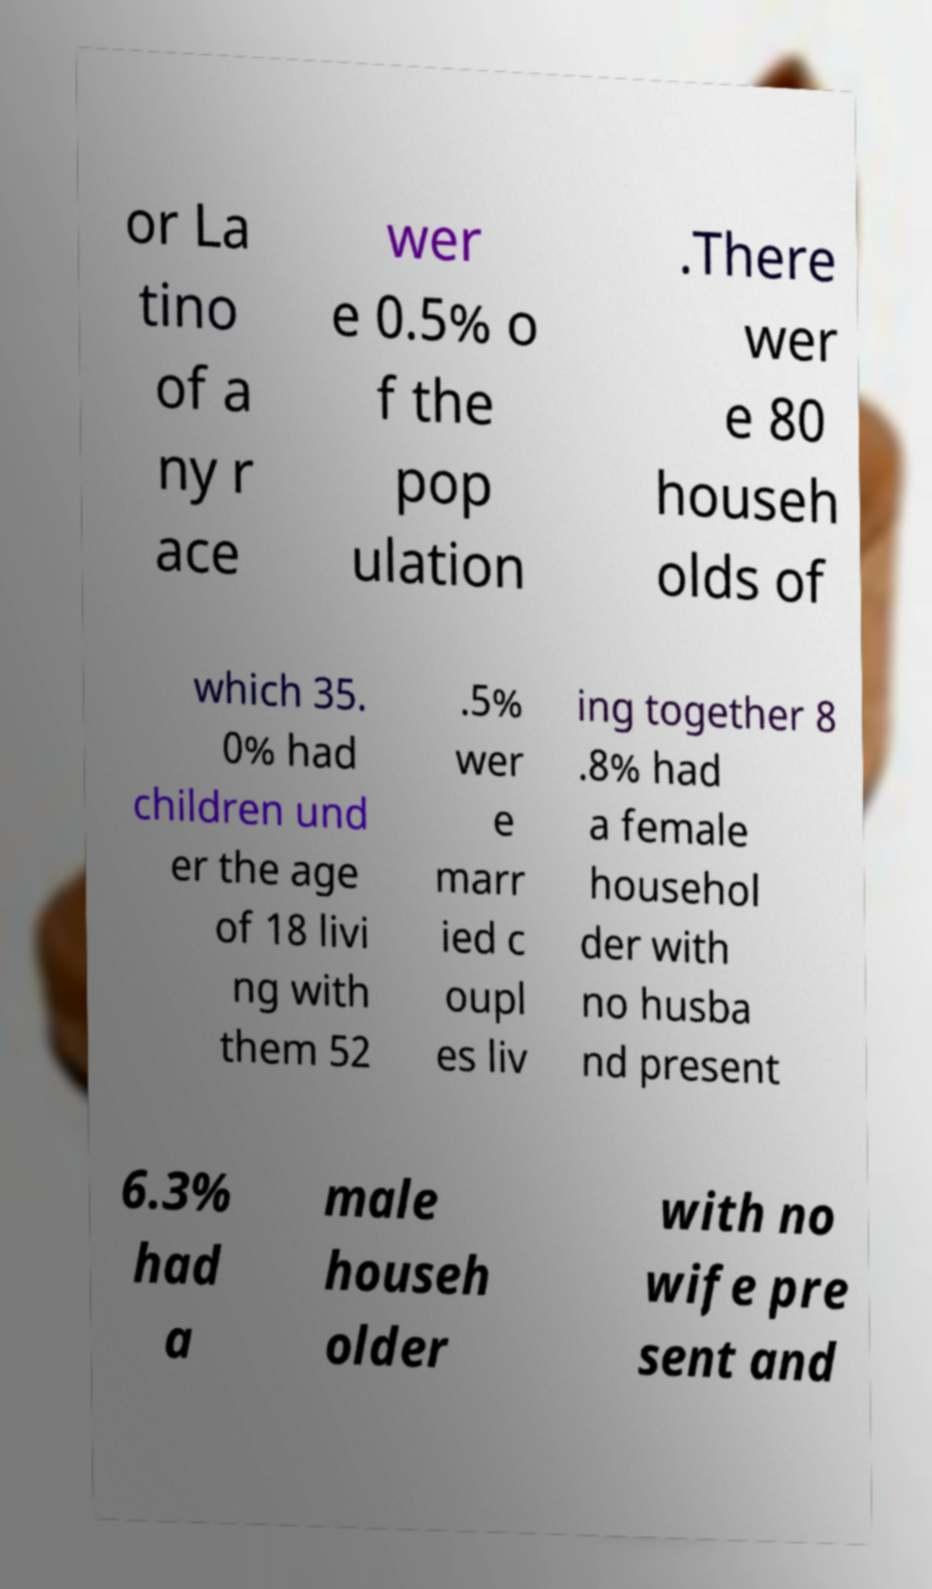There's text embedded in this image that I need extracted. Can you transcribe it verbatim? or La tino of a ny r ace wer e 0.5% o f the pop ulation .There wer e 80 househ olds of which 35. 0% had children und er the age of 18 livi ng with them 52 .5% wer e marr ied c oupl es liv ing together 8 .8% had a female househol der with no husba nd present 6.3% had a male househ older with no wife pre sent and 